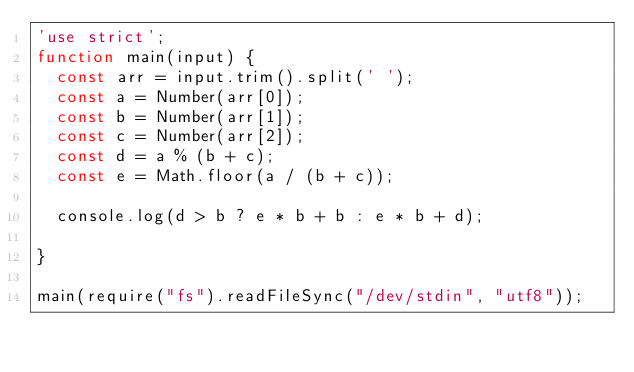<code> <loc_0><loc_0><loc_500><loc_500><_JavaScript_>'use strict';
function main(input) {
  const arr = input.trim().split(' ');
  const a = Number(arr[0]);
  const b = Number(arr[1]);
  const c = Number(arr[2]);
  const d = a % (b + c);
  const e = Math.floor(a / (b + c));

  console.log(d > b ? e * b + b : e * b + d);
  
}

main(require("fs").readFileSync("/dev/stdin", "utf8"));</code> 